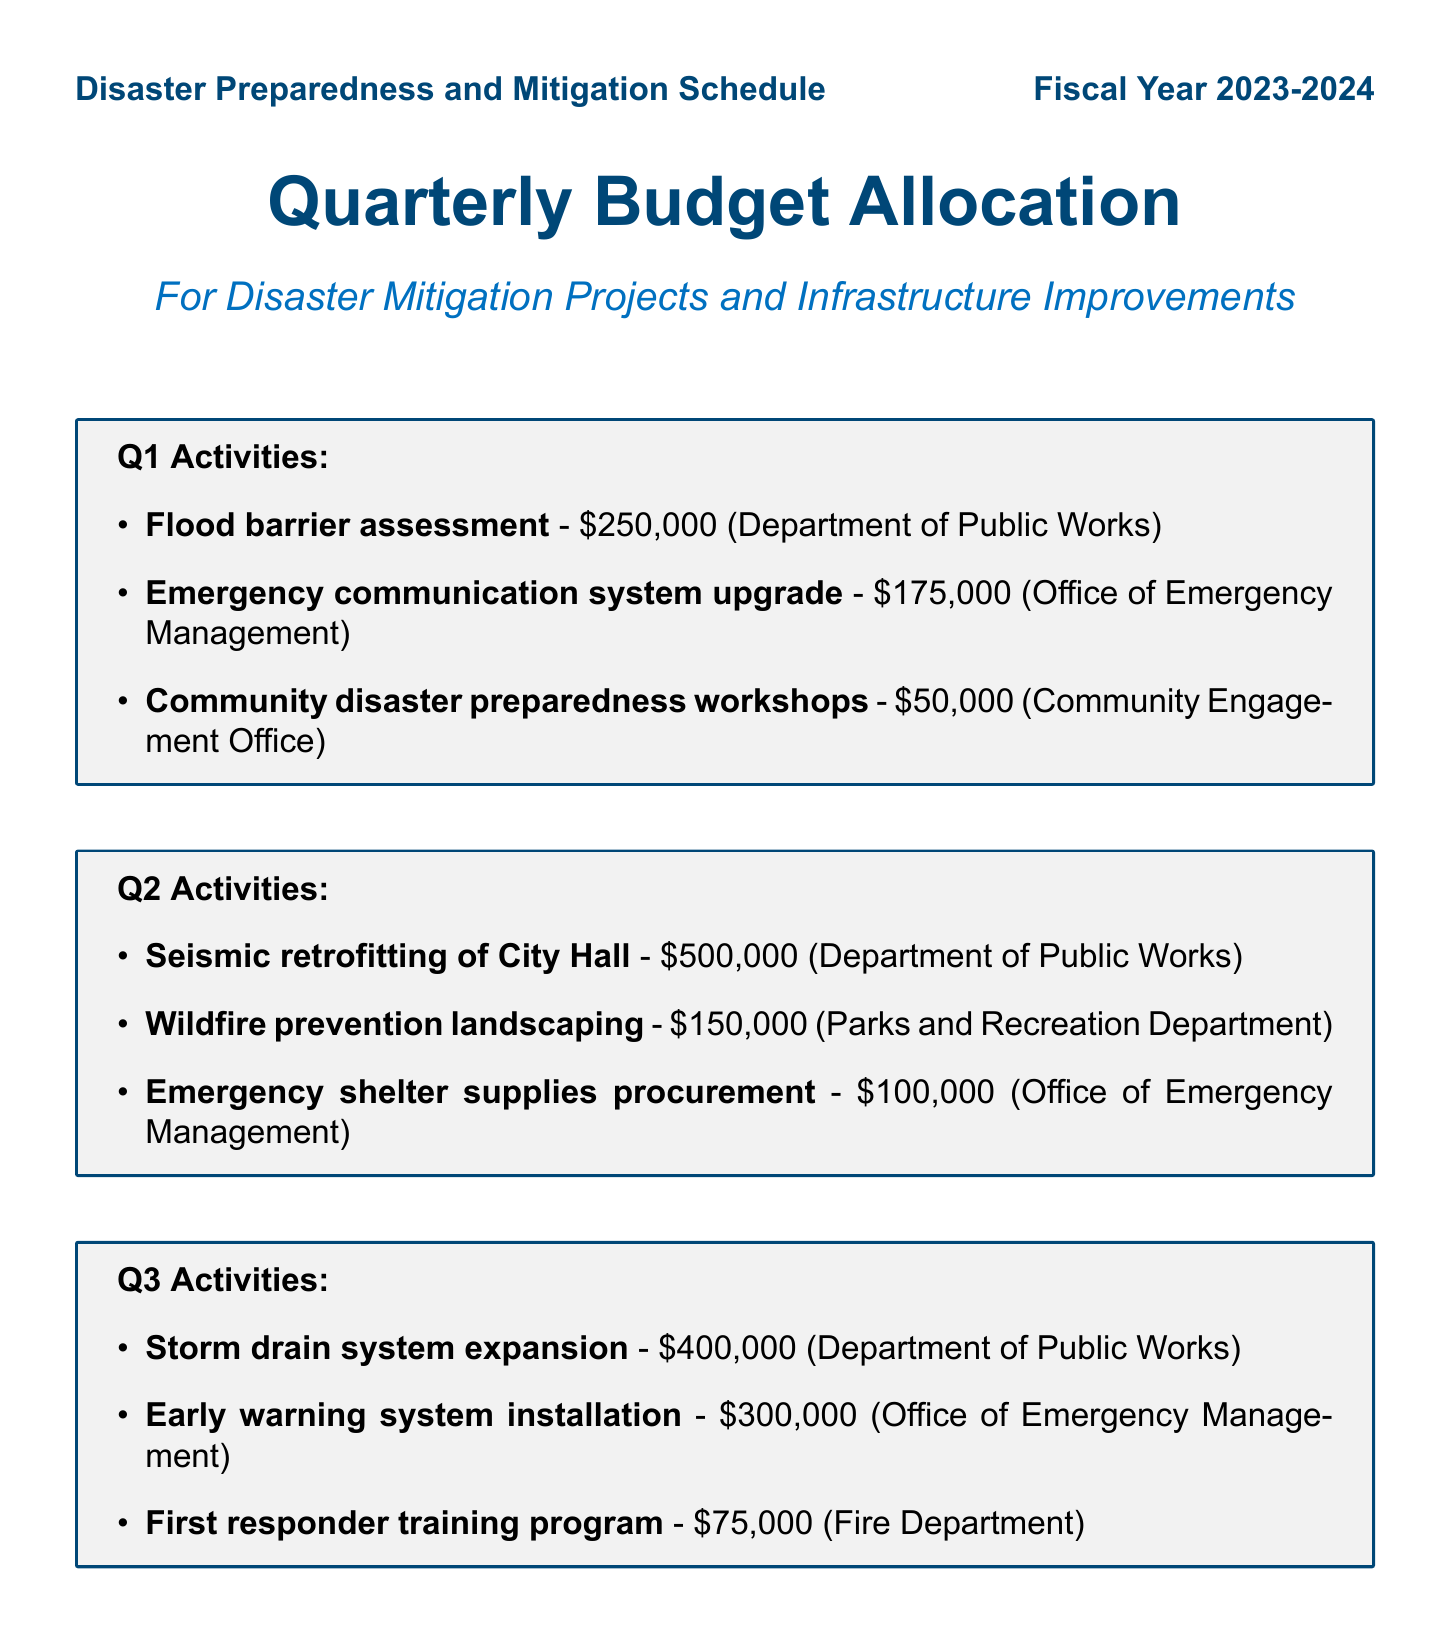What is the total annual budget? The total annual budget is stated at the end of the document and is the sum of all quarterly allocations and continuous programs.
Answer: $3,430,000 Which department is responsible for the storm drain system expansion? The responsible department for the storm drain system expansion is listed under Q3 activities.
Answer: Department of Public Works How much is allocated for the seismic retrofitting of City Hall? The allocation amount for the seismic retrofitting of City Hall is found in Q2 activities.
Answer: $500,000 What is the name of the annual review project? The document specifies that the name of the annual review project is listed under the Annual Review section.
Answer: Year-end disaster preparedness assessment What is the budget for community disaster preparedness workshops? The budget for community disaster preparedness workshops is provided in the Q1 activities section.
Answer: $50,000 What is the duration of the monthly emergency drills program? The monthly emergency drills are part of the Continuous Programs section and are conducted regularly.
Answer: Monthly Which project has the highest budget allocation in Q4? The document itemizes projects in Q4, highlighting the one with the highest allocation.
Answer: Bridge reinforcement project What type of landscaping is implemented in Q2 activities? The Q2 activities section mentions specific landscaping meant to address wildfire risks.
Answer: Wildfire prevention landscaping How much is allocated for the early warning system installation? The allocation can be found in the Q3 activities section, indicating the specific funding for this project.
Answer: $300,000 